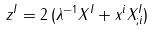Convert formula to latex. <formula><loc_0><loc_0><loc_500><loc_500>z ^ { I } = 2 \, ( \lambda ^ { - 1 } X ^ { I } + x ^ { i } X ^ { I } _ { ; i } )</formula> 